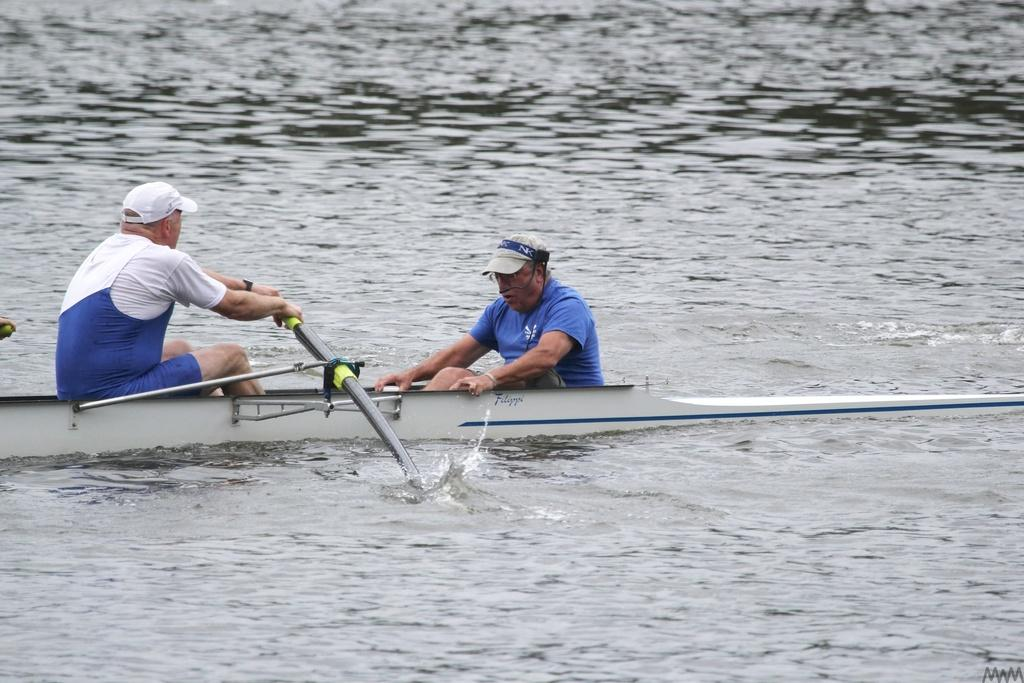How many people are in the image? There are two men in the image. What are the men doing in the image? The men are sitting in a boat and rowing with sticks. What is visible at the bottom of the image? There is water visible at the bottom of the image. What type of mitten is the man wearing on his left hand in the image? There are no mittens present in the image; the men are rowing with sticks. What sound does the alarm make in the image? There is no alarm present in the image. 